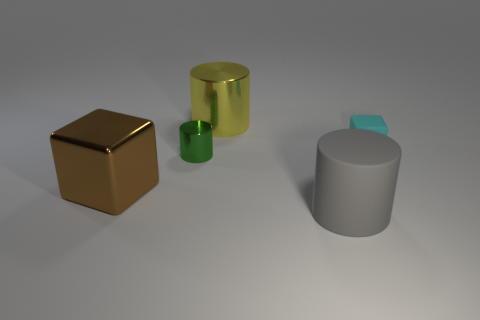Subtract all large cylinders. How many cylinders are left? 1 Add 3 small metallic cylinders. How many objects exist? 8 Subtract all yellow cylinders. How many cylinders are left? 2 Subtract all cylinders. How many objects are left? 2 Subtract 1 cylinders. How many cylinders are left? 2 Subtract all large yellow things. Subtract all large cylinders. How many objects are left? 2 Add 4 small green objects. How many small green objects are left? 5 Add 1 metallic blocks. How many metallic blocks exist? 2 Subtract 1 gray cylinders. How many objects are left? 4 Subtract all brown blocks. Subtract all yellow cylinders. How many blocks are left? 1 